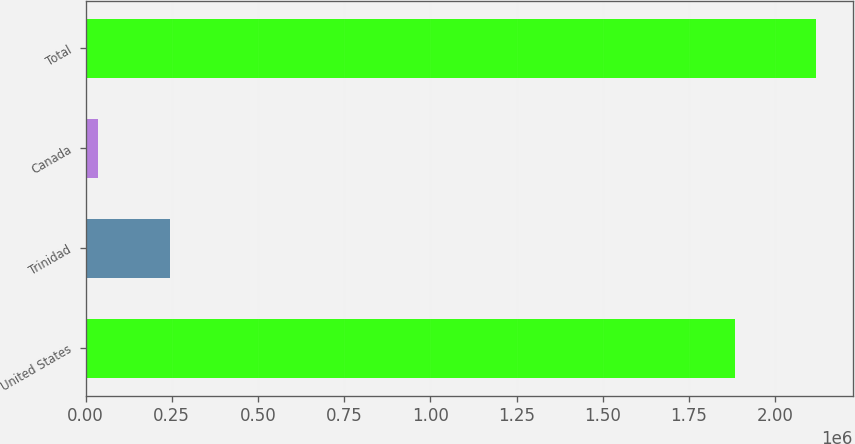Convert chart. <chart><loc_0><loc_0><loc_500><loc_500><bar_chart><fcel>United States<fcel>Trinidad<fcel>Canada<fcel>Total<nl><fcel>1.88449e+06<fcel>244022<fcel>35771<fcel>2.11828e+06<nl></chart> 